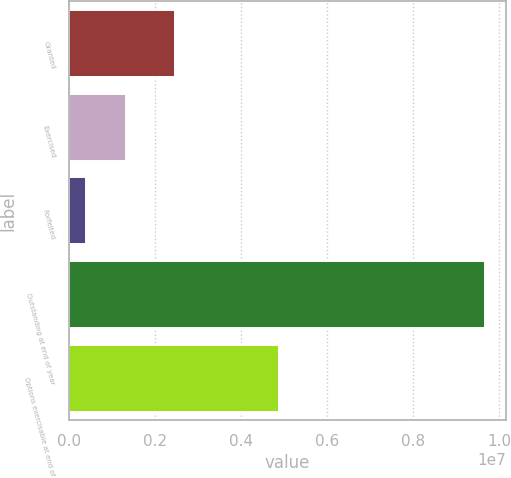Convert chart. <chart><loc_0><loc_0><loc_500><loc_500><bar_chart><fcel>Granted<fcel>Exercised<fcel>Forfeited<fcel>Outstanding at end of year<fcel>Options exercisable at end of<nl><fcel>2.46965e+06<fcel>1.3336e+06<fcel>405794<fcel>9.68382e+06<fcel>4.88448e+06<nl></chart> 